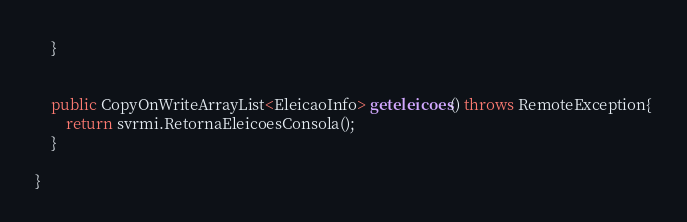Convert code to text. <code><loc_0><loc_0><loc_500><loc_500><_Java_>	}
	
	
	public CopyOnWriteArrayList<EleicaoInfo> geteleicoes() throws RemoteException{
		return svrmi.RetornaEleicoesConsola();
	}

}
</code> 